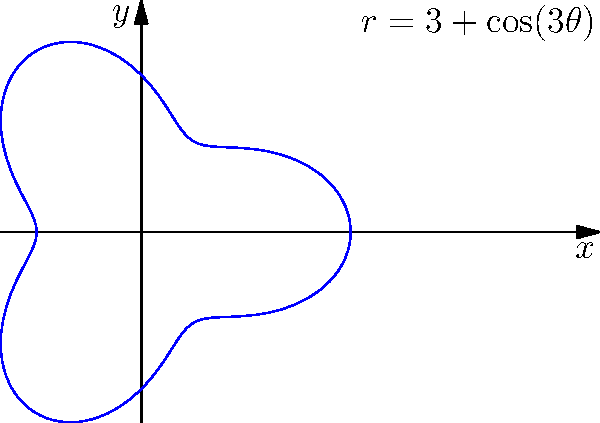As an entrepreneur expanding your cake menu, you want to create a unique circular cake display. You decide to use polar coordinates to design a flower-shaped cake with 3 petals. The equation $r = 3 + \cos(3\theta)$ describes the shape of the cake. What is the maximum radius of the cake in centimeters? To find the maximum radius of the cake, we need to follow these steps:

1. The equation of the cake's shape is given by $r = 3 + \cos(3\theta)$.

2. The cosine function has a range of [-1, 1], meaning $-1 \leq \cos(3\theta) \leq 1$.

3. The maximum value of $\cos(3\theta)$ is 1.

4. To find the maximum radius, we substitute the maximum value of cosine:

   $r_{max} = 3 + 1 = 4$

5. Therefore, the maximum radius of the cake is 4 centimeters.

This design ensures that your circular cake display will have a unique flower shape with 3 petals, making it an attractive addition to your expanded menu.
Answer: 4 cm 